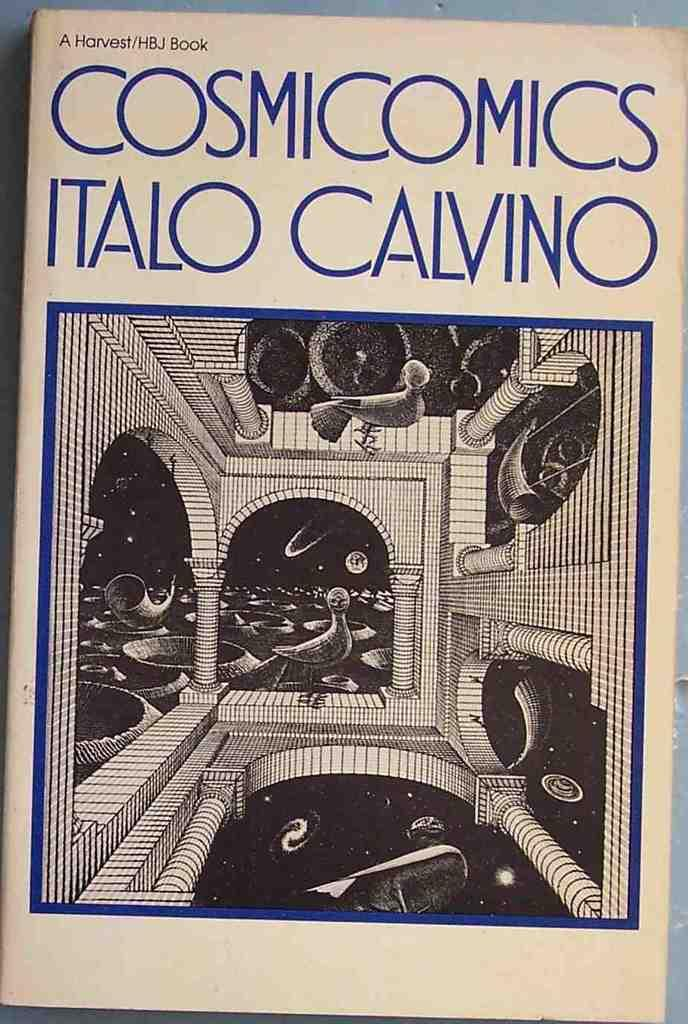<image>
Present a compact description of the photo's key features. A well handled book entitled Cosmicomics that contains interesting drawings. 